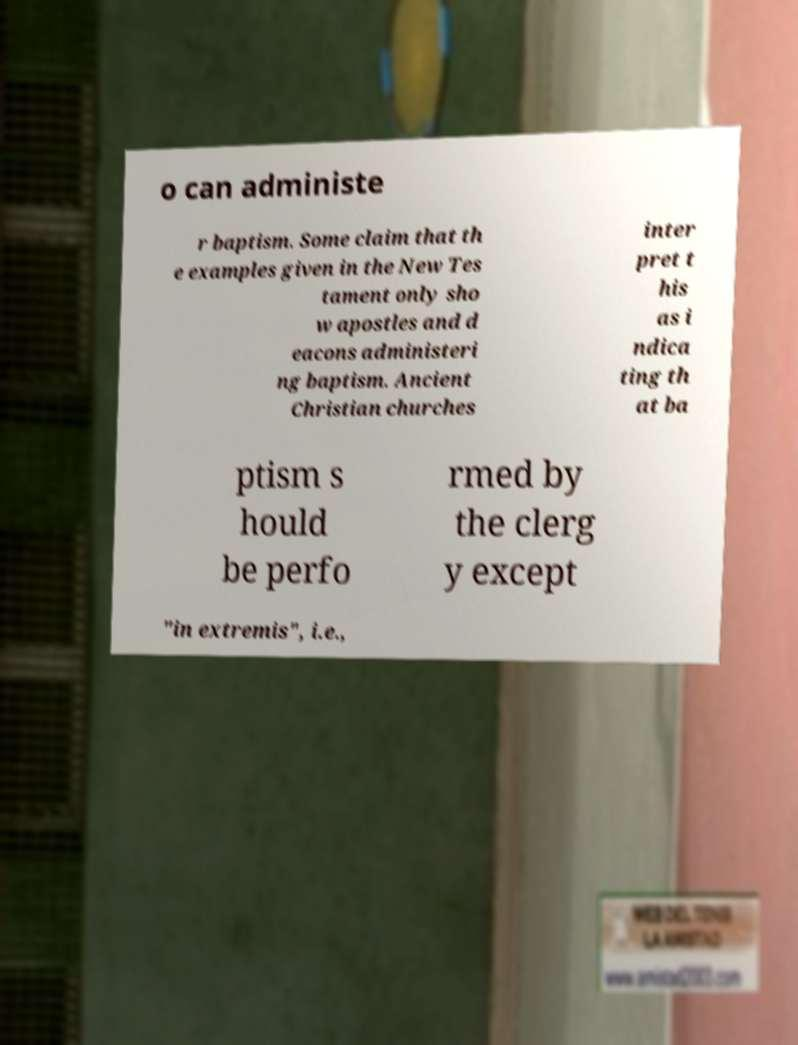What messages or text are displayed in this image? I need them in a readable, typed format. o can administe r baptism. Some claim that th e examples given in the New Tes tament only sho w apostles and d eacons administeri ng baptism. Ancient Christian churches inter pret t his as i ndica ting th at ba ptism s hould be perfo rmed by the clerg y except "in extremis", i.e., 